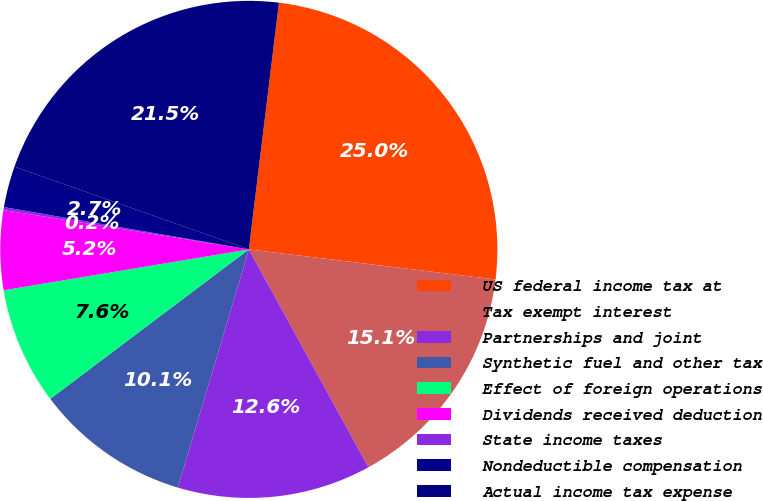<chart> <loc_0><loc_0><loc_500><loc_500><pie_chart><fcel>US federal income tax at<fcel>Tax exempt interest<fcel>Partnerships and joint<fcel>Synthetic fuel and other tax<fcel>Effect of foreign operations<fcel>Dividends received deduction<fcel>State income taxes<fcel>Nondeductible compensation<fcel>Actual income tax expense<nl><fcel>25.0%<fcel>15.08%<fcel>12.6%<fcel>10.12%<fcel>7.64%<fcel>5.16%<fcel>0.19%<fcel>2.68%<fcel>21.53%<nl></chart> 